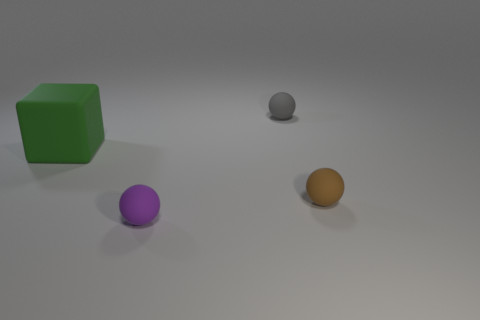Subtract all purple balls. How many balls are left? 2 Add 2 large red matte cubes. How many objects exist? 6 Subtract all brown spheres. How many spheres are left? 2 Subtract all cubes. How many objects are left? 3 Add 4 small brown objects. How many small brown objects are left? 5 Add 4 big green things. How many big green things exist? 5 Subtract 0 brown cylinders. How many objects are left? 4 Subtract all brown spheres. Subtract all purple cylinders. How many spheres are left? 2 Subtract all gray cylinders. How many brown spheres are left? 1 Subtract all small yellow cylinders. Subtract all small gray rubber objects. How many objects are left? 3 